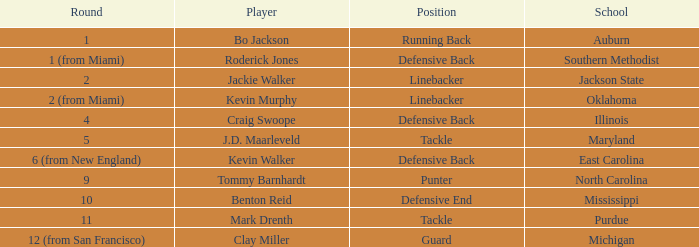Can you parse all the data within this table? {'header': ['Round', 'Player', 'Position', 'School'], 'rows': [['1', 'Bo Jackson', 'Running Back', 'Auburn'], ['1 (from Miami)', 'Roderick Jones', 'Defensive Back', 'Southern Methodist'], ['2', 'Jackie Walker', 'Linebacker', 'Jackson State'], ['2 (from Miami)', 'Kevin Murphy', 'Linebacker', 'Oklahoma'], ['4', 'Craig Swoope', 'Defensive Back', 'Illinois'], ['5', 'J.D. Maarleveld', 'Tackle', 'Maryland'], ['6 (from New England)', 'Kevin Walker', 'Defensive Back', 'East Carolina'], ['9', 'Tommy Barnhardt', 'Punter', 'North Carolina'], ['10', 'Benton Reid', 'Defensive End', 'Mississippi'], ['11', 'Mark Drenth', 'Tackle', 'Purdue'], ['12 (from San Francisco)', 'Clay Miller', 'Guard', 'Michigan']]} What school did bo jackson attend? Auburn. 